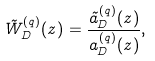Convert formula to latex. <formula><loc_0><loc_0><loc_500><loc_500>\tilde { W } _ { D } ^ { ( q ) } ( z ) = \frac { \tilde { a } _ { D } ^ { ( q ) } ( z ) } { a _ { D } ^ { ( q ) } ( z ) } ,</formula> 